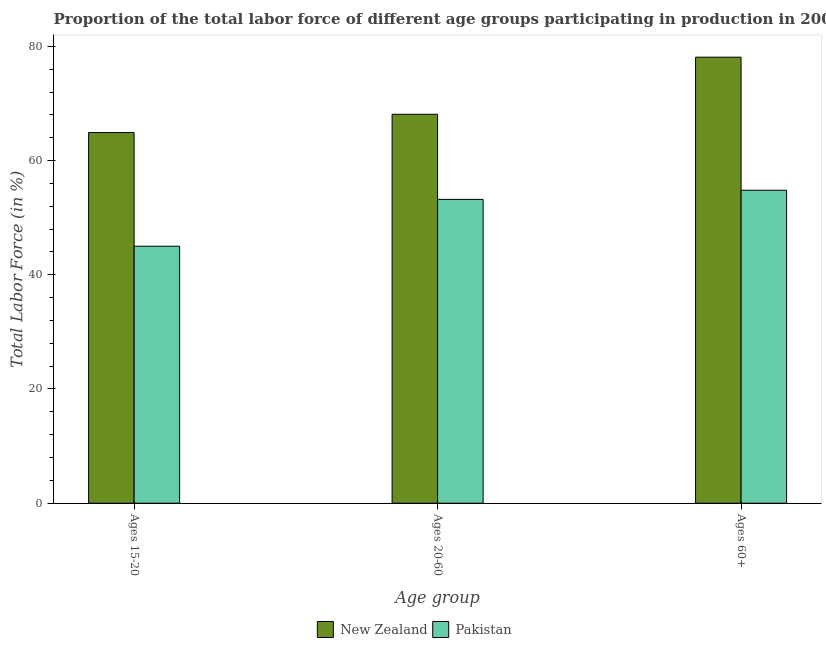How many different coloured bars are there?
Offer a terse response. 2. Are the number of bars per tick equal to the number of legend labels?
Make the answer very short. Yes. Are the number of bars on each tick of the X-axis equal?
Ensure brevity in your answer.  Yes. How many bars are there on the 2nd tick from the left?
Provide a succinct answer. 2. What is the label of the 2nd group of bars from the left?
Provide a succinct answer. Ages 20-60. What is the percentage of labor force within the age group 20-60 in New Zealand?
Make the answer very short. 68.1. Across all countries, what is the maximum percentage of labor force within the age group 20-60?
Ensure brevity in your answer.  68.1. In which country was the percentage of labor force above age 60 maximum?
Offer a terse response. New Zealand. What is the total percentage of labor force within the age group 20-60 in the graph?
Offer a terse response. 121.3. What is the difference between the percentage of labor force within the age group 20-60 in Pakistan and that in New Zealand?
Make the answer very short. -14.9. What is the difference between the percentage of labor force above age 60 in New Zealand and the percentage of labor force within the age group 20-60 in Pakistan?
Your answer should be very brief. 24.9. What is the average percentage of labor force within the age group 15-20 per country?
Your response must be concise. 54.95. What is the difference between the percentage of labor force within the age group 15-20 and percentage of labor force within the age group 20-60 in Pakistan?
Offer a terse response. -8.2. In how many countries, is the percentage of labor force within the age group 20-60 greater than 8 %?
Your response must be concise. 2. What is the ratio of the percentage of labor force above age 60 in Pakistan to that in New Zealand?
Provide a short and direct response. 0.7. Is the percentage of labor force within the age group 15-20 in New Zealand less than that in Pakistan?
Make the answer very short. No. What is the difference between the highest and the second highest percentage of labor force within the age group 20-60?
Give a very brief answer. 14.9. What is the difference between the highest and the lowest percentage of labor force within the age group 20-60?
Give a very brief answer. 14.9. Is the sum of the percentage of labor force within the age group 20-60 in New Zealand and Pakistan greater than the maximum percentage of labor force within the age group 15-20 across all countries?
Offer a very short reply. Yes. What does the 2nd bar from the right in Ages 15-20 represents?
Your answer should be compact. New Zealand. How many bars are there?
Your answer should be very brief. 6. How many countries are there in the graph?
Offer a terse response. 2. What is the difference between two consecutive major ticks on the Y-axis?
Ensure brevity in your answer.  20. Does the graph contain any zero values?
Keep it short and to the point. No. Does the graph contain grids?
Your answer should be very brief. No. Where does the legend appear in the graph?
Your answer should be very brief. Bottom center. How many legend labels are there?
Give a very brief answer. 2. What is the title of the graph?
Make the answer very short. Proportion of the total labor force of different age groups participating in production in 2007. What is the label or title of the X-axis?
Give a very brief answer. Age group. What is the label or title of the Y-axis?
Your response must be concise. Total Labor Force (in %). What is the Total Labor Force (in %) of New Zealand in Ages 15-20?
Offer a very short reply. 64.9. What is the Total Labor Force (in %) in New Zealand in Ages 20-60?
Your answer should be compact. 68.1. What is the Total Labor Force (in %) of Pakistan in Ages 20-60?
Offer a terse response. 53.2. What is the Total Labor Force (in %) of New Zealand in Ages 60+?
Provide a short and direct response. 78.1. What is the Total Labor Force (in %) of Pakistan in Ages 60+?
Your answer should be very brief. 54.8. Across all Age group, what is the maximum Total Labor Force (in %) in New Zealand?
Provide a succinct answer. 78.1. Across all Age group, what is the maximum Total Labor Force (in %) of Pakistan?
Provide a short and direct response. 54.8. Across all Age group, what is the minimum Total Labor Force (in %) of New Zealand?
Keep it short and to the point. 64.9. Across all Age group, what is the minimum Total Labor Force (in %) in Pakistan?
Your answer should be very brief. 45. What is the total Total Labor Force (in %) of New Zealand in the graph?
Your answer should be very brief. 211.1. What is the total Total Labor Force (in %) in Pakistan in the graph?
Your answer should be very brief. 153. What is the difference between the Total Labor Force (in %) in Pakistan in Ages 15-20 and that in Ages 20-60?
Ensure brevity in your answer.  -8.2. What is the difference between the Total Labor Force (in %) in New Zealand in Ages 15-20 and that in Ages 60+?
Offer a terse response. -13.2. What is the difference between the Total Labor Force (in %) in New Zealand in Ages 15-20 and the Total Labor Force (in %) in Pakistan in Ages 20-60?
Make the answer very short. 11.7. What is the difference between the Total Labor Force (in %) of New Zealand in Ages 20-60 and the Total Labor Force (in %) of Pakistan in Ages 60+?
Offer a terse response. 13.3. What is the average Total Labor Force (in %) in New Zealand per Age group?
Your response must be concise. 70.37. What is the difference between the Total Labor Force (in %) of New Zealand and Total Labor Force (in %) of Pakistan in Ages 20-60?
Offer a terse response. 14.9. What is the difference between the Total Labor Force (in %) of New Zealand and Total Labor Force (in %) of Pakistan in Ages 60+?
Ensure brevity in your answer.  23.3. What is the ratio of the Total Labor Force (in %) of New Zealand in Ages 15-20 to that in Ages 20-60?
Keep it short and to the point. 0.95. What is the ratio of the Total Labor Force (in %) of Pakistan in Ages 15-20 to that in Ages 20-60?
Provide a succinct answer. 0.85. What is the ratio of the Total Labor Force (in %) in New Zealand in Ages 15-20 to that in Ages 60+?
Your response must be concise. 0.83. What is the ratio of the Total Labor Force (in %) in Pakistan in Ages 15-20 to that in Ages 60+?
Offer a terse response. 0.82. What is the ratio of the Total Labor Force (in %) of New Zealand in Ages 20-60 to that in Ages 60+?
Your answer should be compact. 0.87. What is the ratio of the Total Labor Force (in %) of Pakistan in Ages 20-60 to that in Ages 60+?
Make the answer very short. 0.97. What is the difference between the highest and the second highest Total Labor Force (in %) in New Zealand?
Your answer should be very brief. 10. 